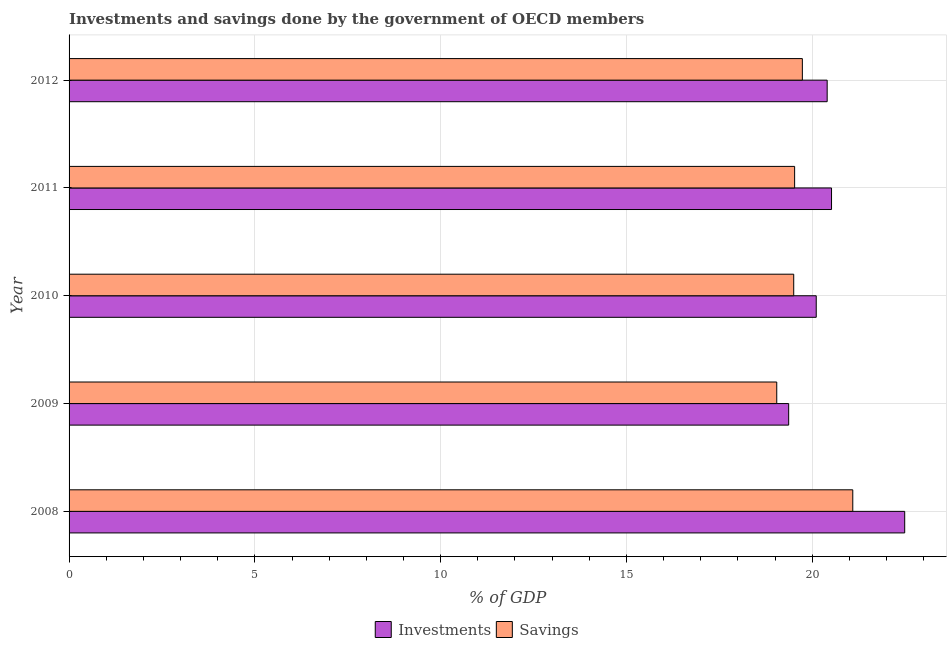How many groups of bars are there?
Your response must be concise. 5. How many bars are there on the 3rd tick from the top?
Keep it short and to the point. 2. How many bars are there on the 2nd tick from the bottom?
Ensure brevity in your answer.  2. What is the investments of government in 2011?
Your response must be concise. 20.52. Across all years, what is the maximum savings of government?
Make the answer very short. 21.09. Across all years, what is the minimum savings of government?
Your answer should be compact. 19.05. In which year was the savings of government maximum?
Give a very brief answer. 2008. What is the total savings of government in the graph?
Offer a terse response. 98.9. What is the difference between the savings of government in 2008 and that in 2009?
Offer a terse response. 2.05. What is the difference between the savings of government in 2010 and the investments of government in 2012?
Your response must be concise. -0.9. What is the average investments of government per year?
Make the answer very short. 20.58. In the year 2008, what is the difference between the savings of government and investments of government?
Offer a very short reply. -1.4. In how many years, is the savings of government greater than 13 %?
Provide a short and direct response. 5. What is the ratio of the investments of government in 2008 to that in 2011?
Keep it short and to the point. 1.1. Is the investments of government in 2008 less than that in 2012?
Your response must be concise. No. Is the difference between the savings of government in 2010 and 2011 greater than the difference between the investments of government in 2010 and 2011?
Provide a short and direct response. Yes. What is the difference between the highest and the second highest investments of government?
Your answer should be very brief. 1.97. What is the difference between the highest and the lowest investments of government?
Keep it short and to the point. 3.12. What does the 1st bar from the top in 2008 represents?
Your answer should be compact. Savings. What does the 1st bar from the bottom in 2011 represents?
Provide a succinct answer. Investments. How many bars are there?
Your response must be concise. 10. Are all the bars in the graph horizontal?
Keep it short and to the point. Yes. Where does the legend appear in the graph?
Keep it short and to the point. Bottom center. What is the title of the graph?
Keep it short and to the point. Investments and savings done by the government of OECD members. Does "International Visitors" appear as one of the legend labels in the graph?
Ensure brevity in your answer.  No. What is the label or title of the X-axis?
Your answer should be compact. % of GDP. What is the label or title of the Y-axis?
Make the answer very short. Year. What is the % of GDP of Investments in 2008?
Your answer should be very brief. 22.49. What is the % of GDP of Savings in 2008?
Ensure brevity in your answer.  21.09. What is the % of GDP of Investments in 2009?
Keep it short and to the point. 19.37. What is the % of GDP of Savings in 2009?
Give a very brief answer. 19.05. What is the % of GDP of Investments in 2010?
Ensure brevity in your answer.  20.11. What is the % of GDP of Savings in 2010?
Provide a short and direct response. 19.5. What is the % of GDP of Investments in 2011?
Make the answer very short. 20.52. What is the % of GDP in Savings in 2011?
Your response must be concise. 19.53. What is the % of GDP of Investments in 2012?
Your response must be concise. 20.4. What is the % of GDP of Savings in 2012?
Your response must be concise. 19.74. Across all years, what is the maximum % of GDP of Investments?
Your answer should be very brief. 22.49. Across all years, what is the maximum % of GDP in Savings?
Give a very brief answer. 21.09. Across all years, what is the minimum % of GDP in Investments?
Offer a very short reply. 19.37. Across all years, what is the minimum % of GDP in Savings?
Provide a succinct answer. 19.05. What is the total % of GDP in Investments in the graph?
Give a very brief answer. 102.89. What is the total % of GDP in Savings in the graph?
Your answer should be compact. 98.9. What is the difference between the % of GDP in Investments in 2008 and that in 2009?
Your answer should be very brief. 3.12. What is the difference between the % of GDP in Savings in 2008 and that in 2009?
Make the answer very short. 2.05. What is the difference between the % of GDP of Investments in 2008 and that in 2010?
Ensure brevity in your answer.  2.38. What is the difference between the % of GDP of Savings in 2008 and that in 2010?
Provide a succinct answer. 1.59. What is the difference between the % of GDP in Investments in 2008 and that in 2011?
Your answer should be compact. 1.97. What is the difference between the % of GDP of Savings in 2008 and that in 2011?
Your answer should be very brief. 1.57. What is the difference between the % of GDP in Investments in 2008 and that in 2012?
Your answer should be very brief. 2.09. What is the difference between the % of GDP in Savings in 2008 and that in 2012?
Your response must be concise. 1.36. What is the difference between the % of GDP in Investments in 2009 and that in 2010?
Your response must be concise. -0.74. What is the difference between the % of GDP in Savings in 2009 and that in 2010?
Ensure brevity in your answer.  -0.46. What is the difference between the % of GDP of Investments in 2009 and that in 2011?
Keep it short and to the point. -1.15. What is the difference between the % of GDP of Savings in 2009 and that in 2011?
Make the answer very short. -0.48. What is the difference between the % of GDP of Investments in 2009 and that in 2012?
Give a very brief answer. -1.04. What is the difference between the % of GDP of Savings in 2009 and that in 2012?
Your answer should be compact. -0.69. What is the difference between the % of GDP in Investments in 2010 and that in 2011?
Give a very brief answer. -0.41. What is the difference between the % of GDP of Savings in 2010 and that in 2011?
Provide a succinct answer. -0.02. What is the difference between the % of GDP of Investments in 2010 and that in 2012?
Offer a terse response. -0.29. What is the difference between the % of GDP in Savings in 2010 and that in 2012?
Keep it short and to the point. -0.23. What is the difference between the % of GDP in Investments in 2011 and that in 2012?
Make the answer very short. 0.12. What is the difference between the % of GDP of Savings in 2011 and that in 2012?
Offer a very short reply. -0.21. What is the difference between the % of GDP of Investments in 2008 and the % of GDP of Savings in 2009?
Make the answer very short. 3.44. What is the difference between the % of GDP of Investments in 2008 and the % of GDP of Savings in 2010?
Make the answer very short. 2.99. What is the difference between the % of GDP of Investments in 2008 and the % of GDP of Savings in 2011?
Ensure brevity in your answer.  2.96. What is the difference between the % of GDP of Investments in 2008 and the % of GDP of Savings in 2012?
Give a very brief answer. 2.75. What is the difference between the % of GDP in Investments in 2009 and the % of GDP in Savings in 2010?
Your answer should be compact. -0.14. What is the difference between the % of GDP in Investments in 2009 and the % of GDP in Savings in 2011?
Provide a succinct answer. -0.16. What is the difference between the % of GDP in Investments in 2009 and the % of GDP in Savings in 2012?
Provide a succinct answer. -0.37. What is the difference between the % of GDP in Investments in 2010 and the % of GDP in Savings in 2011?
Offer a very short reply. 0.58. What is the difference between the % of GDP in Investments in 2010 and the % of GDP in Savings in 2012?
Your answer should be compact. 0.37. What is the difference between the % of GDP of Investments in 2011 and the % of GDP of Savings in 2012?
Offer a very short reply. 0.79. What is the average % of GDP of Investments per year?
Give a very brief answer. 20.58. What is the average % of GDP of Savings per year?
Your answer should be very brief. 19.78. In the year 2008, what is the difference between the % of GDP of Investments and % of GDP of Savings?
Provide a short and direct response. 1.4. In the year 2009, what is the difference between the % of GDP in Investments and % of GDP in Savings?
Offer a terse response. 0.32. In the year 2010, what is the difference between the % of GDP of Investments and % of GDP of Savings?
Your answer should be very brief. 0.61. In the year 2011, what is the difference between the % of GDP of Investments and % of GDP of Savings?
Make the answer very short. 0.99. In the year 2012, what is the difference between the % of GDP in Investments and % of GDP in Savings?
Offer a terse response. 0.67. What is the ratio of the % of GDP of Investments in 2008 to that in 2009?
Offer a very short reply. 1.16. What is the ratio of the % of GDP in Savings in 2008 to that in 2009?
Ensure brevity in your answer.  1.11. What is the ratio of the % of GDP of Investments in 2008 to that in 2010?
Ensure brevity in your answer.  1.12. What is the ratio of the % of GDP of Savings in 2008 to that in 2010?
Ensure brevity in your answer.  1.08. What is the ratio of the % of GDP in Investments in 2008 to that in 2011?
Provide a succinct answer. 1.1. What is the ratio of the % of GDP of Savings in 2008 to that in 2011?
Your answer should be very brief. 1.08. What is the ratio of the % of GDP in Investments in 2008 to that in 2012?
Your response must be concise. 1.1. What is the ratio of the % of GDP of Savings in 2008 to that in 2012?
Ensure brevity in your answer.  1.07. What is the ratio of the % of GDP of Investments in 2009 to that in 2010?
Your answer should be very brief. 0.96. What is the ratio of the % of GDP of Savings in 2009 to that in 2010?
Your answer should be compact. 0.98. What is the ratio of the % of GDP in Investments in 2009 to that in 2011?
Provide a succinct answer. 0.94. What is the ratio of the % of GDP of Savings in 2009 to that in 2011?
Offer a terse response. 0.98. What is the ratio of the % of GDP of Investments in 2009 to that in 2012?
Make the answer very short. 0.95. What is the ratio of the % of GDP in Savings in 2009 to that in 2012?
Ensure brevity in your answer.  0.97. What is the ratio of the % of GDP of Investments in 2010 to that in 2011?
Make the answer very short. 0.98. What is the ratio of the % of GDP of Savings in 2010 to that in 2011?
Give a very brief answer. 1. What is the ratio of the % of GDP of Investments in 2010 to that in 2012?
Ensure brevity in your answer.  0.99. What is the ratio of the % of GDP of Savings in 2011 to that in 2012?
Ensure brevity in your answer.  0.99. What is the difference between the highest and the second highest % of GDP of Investments?
Your answer should be very brief. 1.97. What is the difference between the highest and the second highest % of GDP in Savings?
Give a very brief answer. 1.36. What is the difference between the highest and the lowest % of GDP in Investments?
Keep it short and to the point. 3.12. What is the difference between the highest and the lowest % of GDP in Savings?
Offer a terse response. 2.05. 